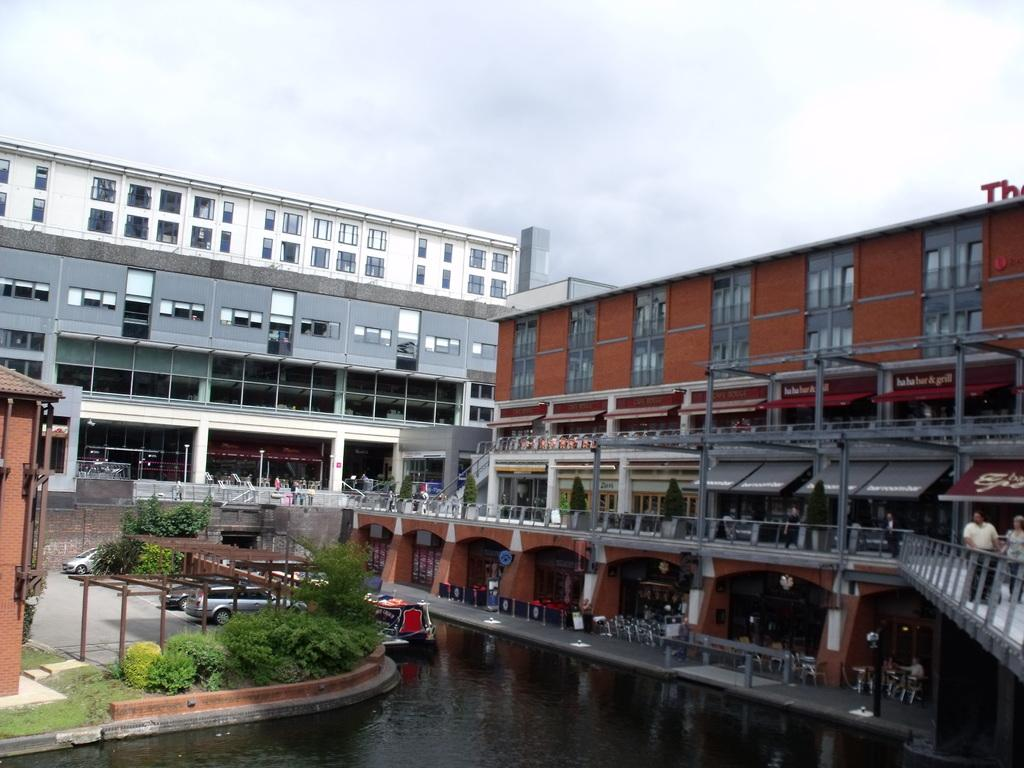How many buildings can be seen in the image? There are two buildings in the image. What else is present in the image besides the buildings? There are trees and cars parked in a parking zone in the image. What are the people in the image doing? Two persons are standing towards the left side of the image. How many children are sitting on the observation chair in the image? There is no observation chair or children present in the image. 